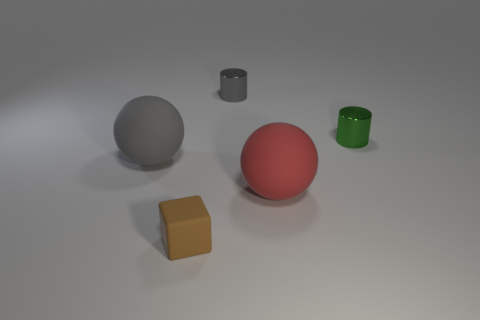Add 1 big cyan shiny things. How many objects exist? 6 Subtract all cubes. How many objects are left? 4 Add 5 green shiny things. How many green shiny things exist? 6 Subtract 0 green cubes. How many objects are left? 5 Subtract all large red matte objects. Subtract all tiny objects. How many objects are left? 1 Add 4 gray rubber objects. How many gray rubber objects are left? 5 